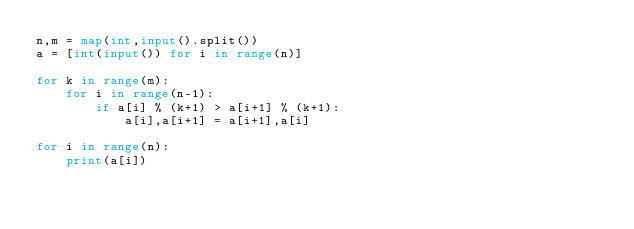Convert code to text. <code><loc_0><loc_0><loc_500><loc_500><_Python_>n,m = map(int,input().split())
a = [int(input()) for i in range(n)]

for k in range(m):
    for i in range(n-1):
        if a[i] % (k+1) > a[i+1] % (k+1):
            a[i],a[i+1] = a[i+1],a[i]

for i in range(n):
    print(a[i])
</code> 